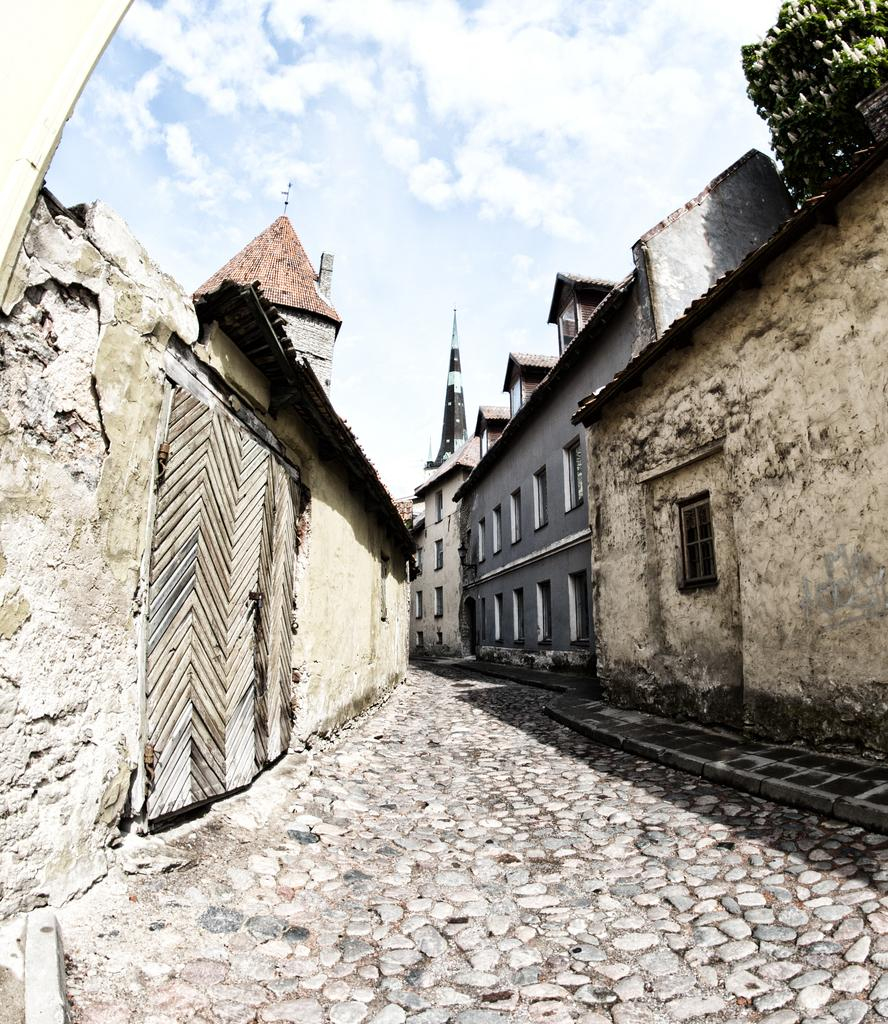What type of structures can be seen in the image? There are buildings in the image. What can be seen beneath the buildings in the image? The ground is visible in the image. What type of vegetation is present in the top right corner of the image? There are plants with flowers in the top right corner of the image. What is visible above the buildings in the image? The sky is visible in the image. What can be observed in the sky in the image? Clouds are present in the sky. Can you tell me how many cows are grazing in the image? There are no cows present in the image. What type of emotion is expressed by the buildings in the image? Buildings do not express emotions; they are inanimate objects. 